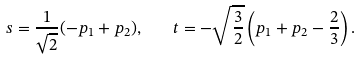Convert formula to latex. <formula><loc_0><loc_0><loc_500><loc_500>s = \frac { 1 } { \sqrt { 2 } } ( - p _ { 1 } + p _ { 2 } ) , \quad t = - \sqrt { \frac { 3 } { 2 } } \left ( p _ { 1 } + p _ { 2 } - \frac { 2 } { 3 } \right ) .</formula> 